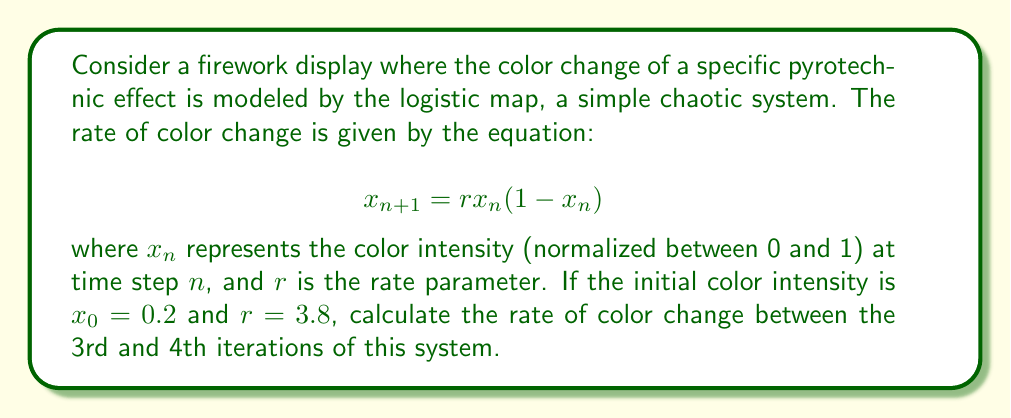Can you solve this math problem? To solve this problem, we need to follow these steps:

1) First, let's calculate the color intensities for the first 4 iterations:

   For $n = 0$: $x_0 = 0.2$ (given)
   
   For $n = 1$: $x_1 = 3.8 \cdot 0.2 \cdot (1-0.2) = 0.608$
   
   For $n = 2$: $x_2 = 3.8 \cdot 0.608 \cdot (1-0.608) = 0.90573824$
   
   For $n = 3$: $x_3 = 3.8 \cdot 0.90573824 \cdot (1-0.90573824) = 0.32819488$
   
   For $n = 4$: $x_4 = 3.8 \cdot 0.32819488 \cdot (1-0.32819488) = 0.84132378$

2) The rate of change between the 3rd and 4th iterations is the difference between $x_4$ and $x_3$:

   Rate of change = $x_4 - x_3 = 0.84132378 - 0.32819488 = 0.51312890$

3) This represents the change in color intensity over one time step. To get the rate of change, we divide by the time step, which in this discrete system is 1.

Therefore, the rate of color change between the 3rd and 4th iterations is 0.51312890 per time step.
Answer: 0.51312890 per time step 